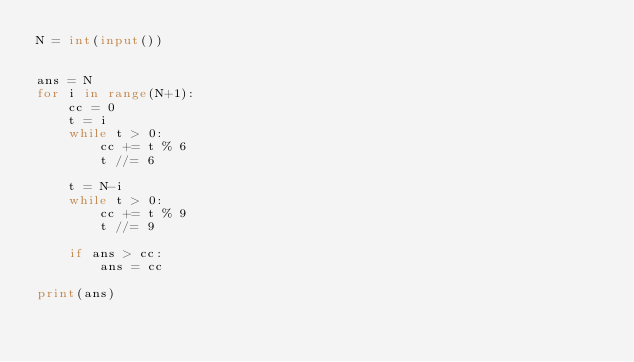<code> <loc_0><loc_0><loc_500><loc_500><_Python_>N = int(input())


ans = N
for i in range(N+1):
    cc = 0
    t = i
    while t > 0:
        cc += t % 6
        t //= 6

    t = N-i
    while t > 0:
        cc += t % 9
        t //= 9

    if ans > cc:
        ans = cc

print(ans)</code> 